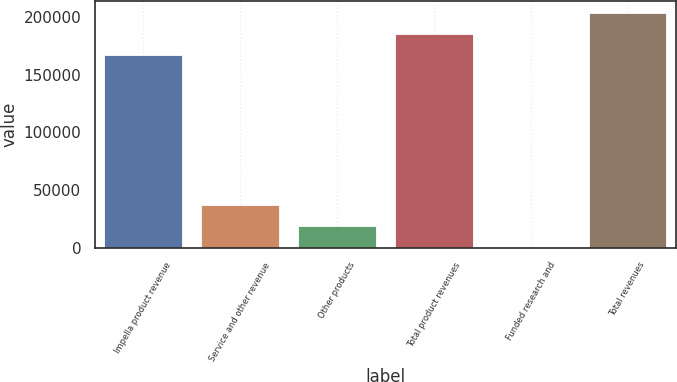Convert chart. <chart><loc_0><loc_0><loc_500><loc_500><bar_chart><fcel>Impella product revenue<fcel>Service and other revenue<fcel>Other products<fcel>Total product revenues<fcel>Funded research and<fcel>Total revenues<nl><fcel>166971<fcel>37019<fcel>18691<fcel>185299<fcel>363<fcel>203627<nl></chart> 